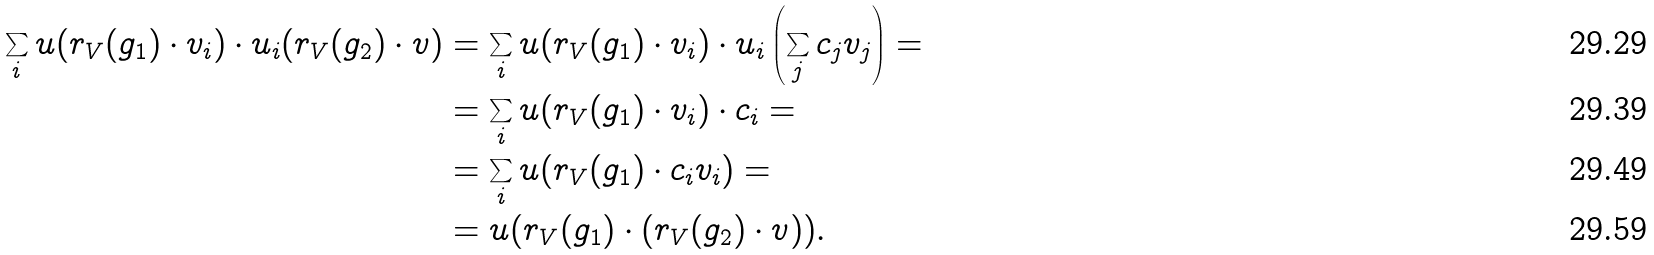<formula> <loc_0><loc_0><loc_500><loc_500>\sum _ { i } u ( r _ { V } ( g _ { 1 } ) \cdot v _ { i } ) \cdot u _ { i } ( r _ { V } ( g _ { 2 } ) \cdot v ) & = \sum _ { i } u ( r _ { V } ( g _ { 1 } ) \cdot v _ { i } ) \cdot u _ { i } \left ( \sum _ { j } c _ { j } v _ { j } \right ) = \\ & = \sum _ { i } u ( r _ { V } ( g _ { 1 } ) \cdot v _ { i } ) \cdot c _ { i } = \\ & = \sum _ { i } u ( r _ { V } ( g _ { 1 } ) \cdot c _ { i } v _ { i } ) = \\ & = u ( r _ { V } ( g _ { 1 } ) \cdot ( r _ { V } ( g _ { 2 } ) \cdot v ) ) .</formula> 